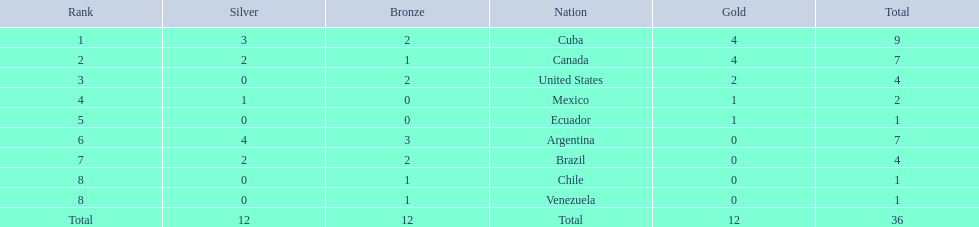Which nations won a gold medal in canoeing in the 2011 pan american games? Cuba, Canada, United States, Mexico, Ecuador. Which of these did not win any silver medals? United States. Can you give me this table in json format? {'header': ['Rank', 'Silver', 'Bronze', 'Nation', 'Gold', 'Total'], 'rows': [['1', '3', '2', 'Cuba', '4', '9'], ['2', '2', '1', 'Canada', '4', '7'], ['3', '0', '2', 'United States', '2', '4'], ['4', '1', '0', 'Mexico', '1', '2'], ['5', '0', '0', 'Ecuador', '1', '1'], ['6', '4', '3', 'Argentina', '0', '7'], ['7', '2', '2', 'Brazil', '0', '4'], ['8', '0', '1', 'Chile', '0', '1'], ['8', '0', '1', 'Venezuela', '0', '1'], ['Total', '12', '12', 'Total', '12', '36']]} 